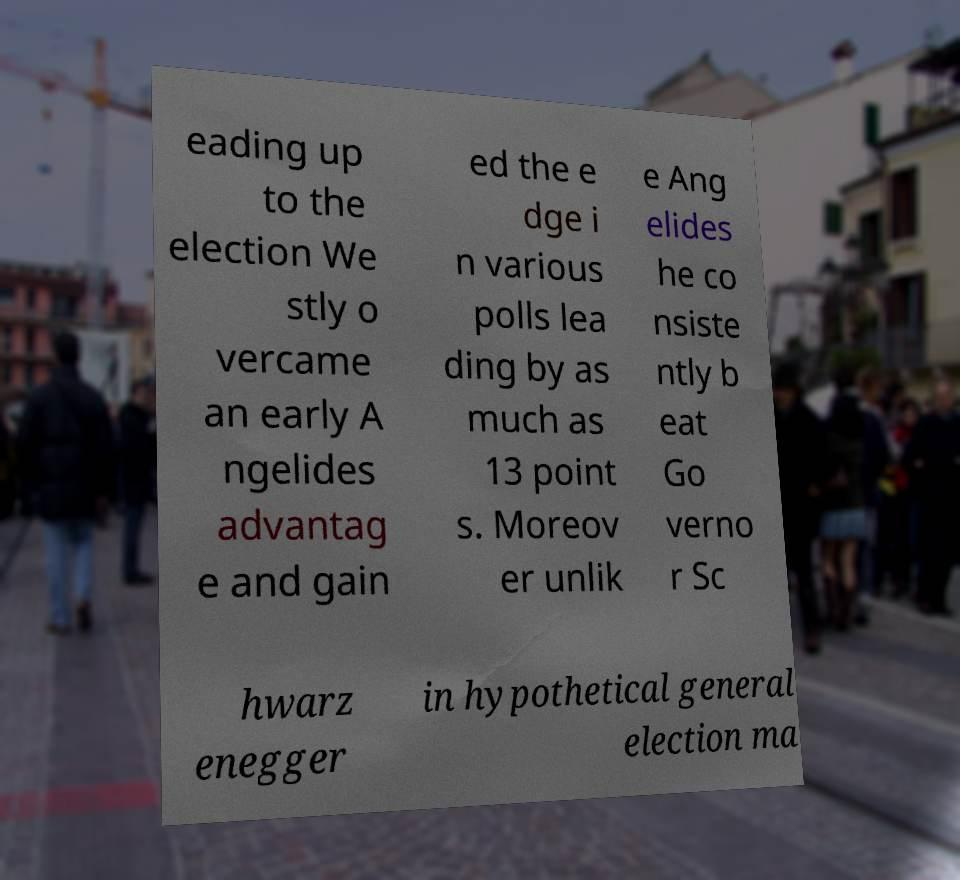For documentation purposes, I need the text within this image transcribed. Could you provide that? eading up to the election We stly o vercame an early A ngelides advantag e and gain ed the e dge i n various polls lea ding by as much as 13 point s. Moreov er unlik e Ang elides he co nsiste ntly b eat Go verno r Sc hwarz enegger in hypothetical general election ma 